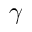Convert formula to latex. <formula><loc_0><loc_0><loc_500><loc_500>\gamma</formula> 